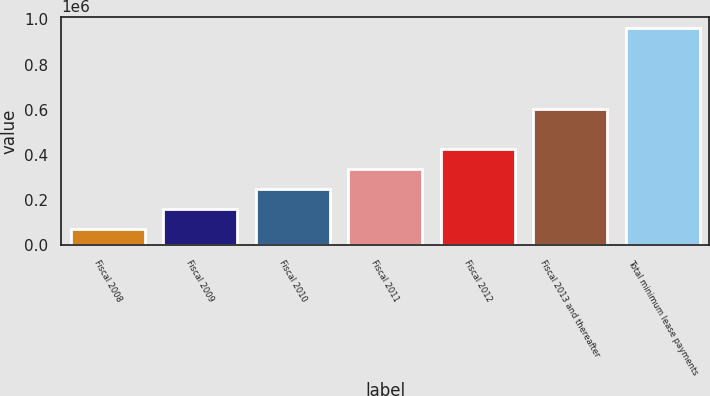Convert chart to OTSL. <chart><loc_0><loc_0><loc_500><loc_500><bar_chart><fcel>Fiscal 2008<fcel>Fiscal 2009<fcel>Fiscal 2010<fcel>Fiscal 2011<fcel>Fiscal 2012<fcel>Fiscal 2013 and thereafter<fcel>Total minimum lease payments<nl><fcel>71041<fcel>160309<fcel>249578<fcel>338846<fcel>428115<fcel>602955<fcel>963725<nl></chart> 